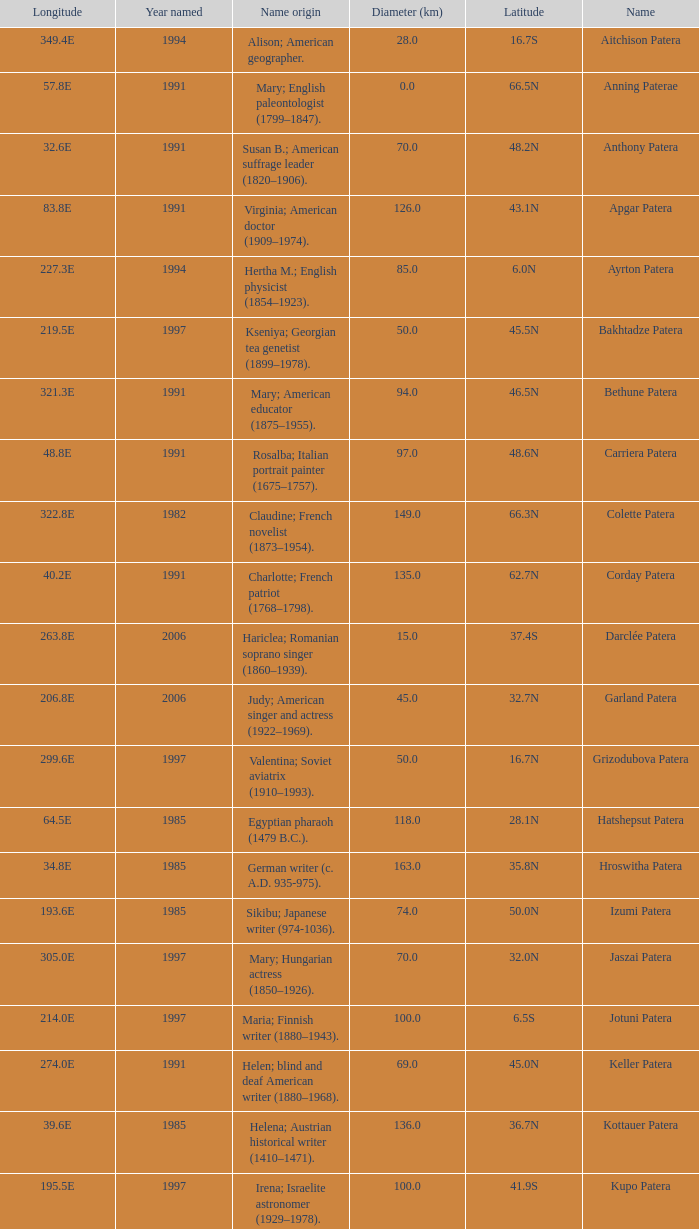What is the origin of the name of Keller Patera?  Helen; blind and deaf American writer (1880–1968). 